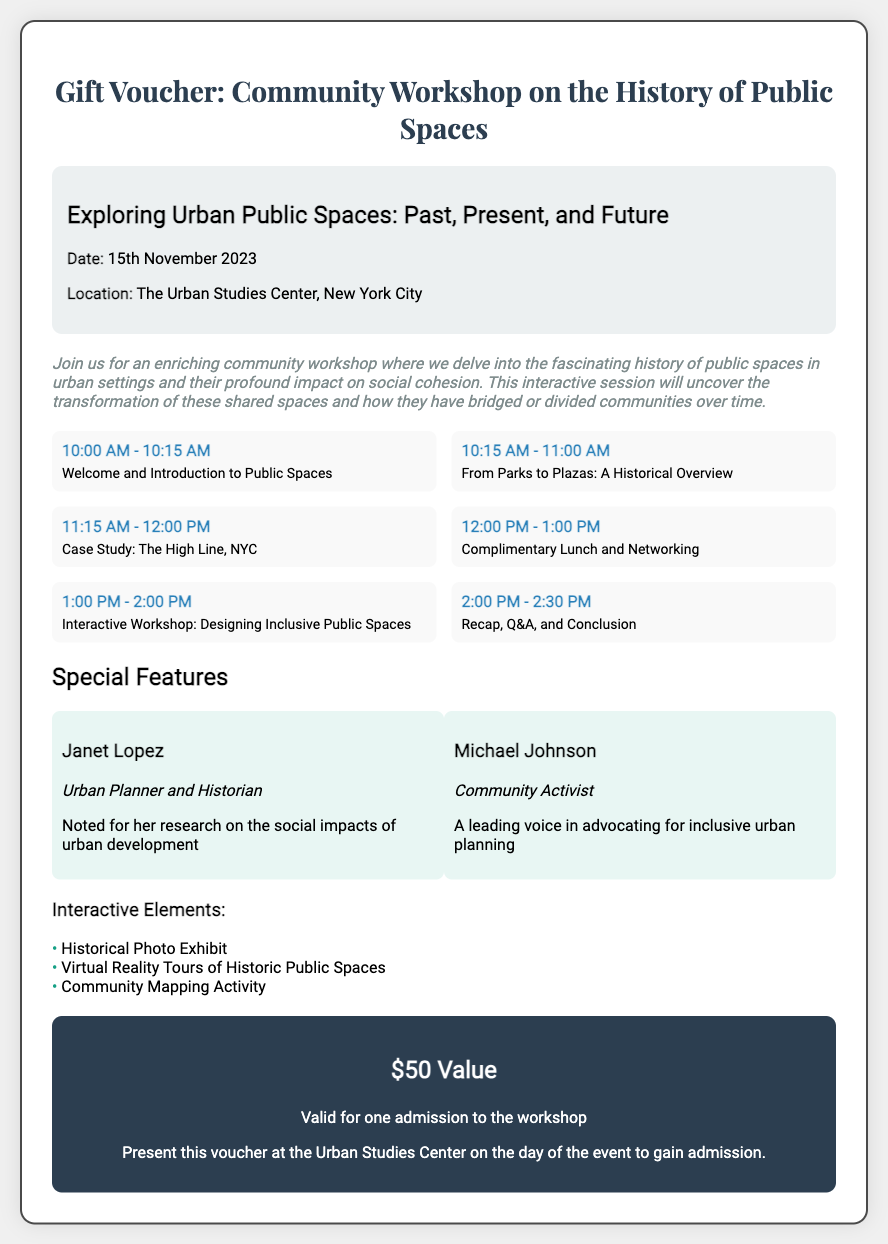what is the date of the workshop? The date of the workshop is explicitly mentioned in the event details section of the document.
Answer: 15th November 2023 where is the workshop located? The location of the workshop is specified under the event details section.
Answer: The Urban Studies Center, New York City who is one of the guest speakers? The document lists guest speakers under the special features section, providing their names and roles.
Answer: Janet Lopez what is the value of the gift voucher? The value of the gift voucher is provided towards the end of the document.
Answer: $50 Value what time does the workshop start? The starting time of the workshop is available in the agenda section.
Answer: 10:00 AM what is one of the interactive elements mentioned? The document lists several interactive elements under the special features section.
Answer: Historical Photo Exhibit how long is the complimentary lunch and networking session? The agenda section specifies the duration of this session, which is noted in the schedule.
Answer: 1 hour what is the topic of the first session in the agenda? The first agenda item outlines the initial session's title.
Answer: Welcome and Introduction to Public Spaces who is the community activist guest speaker? The document identifies guest speakers, including their roles and expertise.
Answer: Michael Johnson 